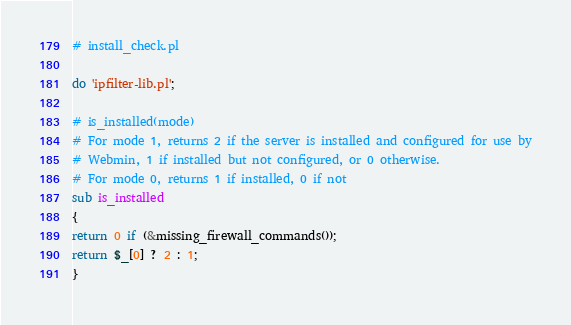Convert code to text. <code><loc_0><loc_0><loc_500><loc_500><_Perl_># install_check.pl

do 'ipfilter-lib.pl';

# is_installed(mode)
# For mode 1, returns 2 if the server is installed and configured for use by
# Webmin, 1 if installed but not configured, or 0 otherwise.
# For mode 0, returns 1 if installed, 0 if not
sub is_installed
{
return 0 if (&missing_firewall_commands());
return $_[0] ? 2 : 1;
}

</code> 